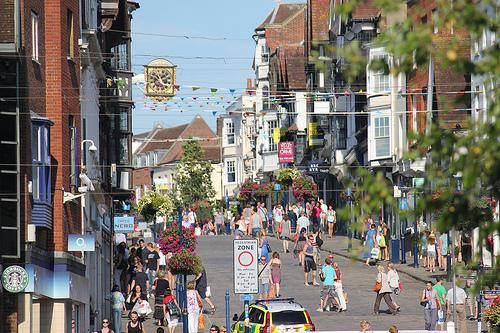Question: what hangs between the buildings?
Choices:
A. Banners.
B. Flags.
C. Carpets.
D. Curtains.
Answer with the letter. Answer: A Question: why is it so bright?
Choices:
A. It's daytime.
B. It's summer.
C. It's sunny.
D. The weather is clear.
Answer with the letter. Answer: A Question: how is the weather?
Choices:
A. Hot.
B. Bright.
C. Clear.
D. Sunny.
Answer with the letter. Answer: D Question: what are the people doing?
Choices:
A. Strolling.
B. Walking.
C. Hiking.
D. Sauntering.
Answer with the letter. Answer: B Question: where is the zone sign?
Choices:
A. Between other signs.
B. The middle.
C. Next to the street.
D. In the center.
Answer with the letter. Answer: B Question: when was this picture taken?
Choices:
A. After lunch.
B. In the evening.
C. Before sunset.
D. In the afternoon.
Answer with the letter. Answer: D Question: what shape is the sign?
Choices:
A. Rectangle.
B. A polyon.
C. A rhombus.
D. Oblong.
Answer with the letter. Answer: A 